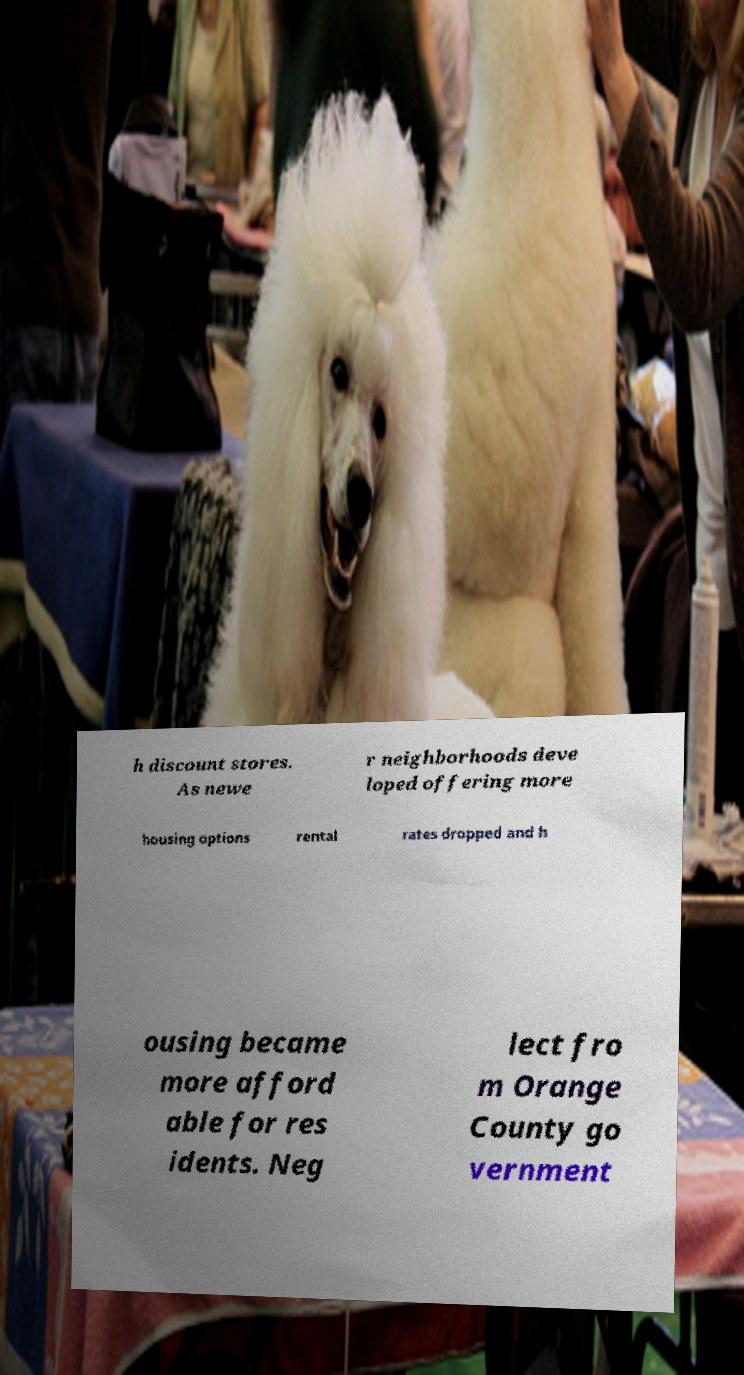Please read and relay the text visible in this image. What does it say? h discount stores. As newe r neighborhoods deve loped offering more housing options rental rates dropped and h ousing became more afford able for res idents. Neg lect fro m Orange County go vernment 